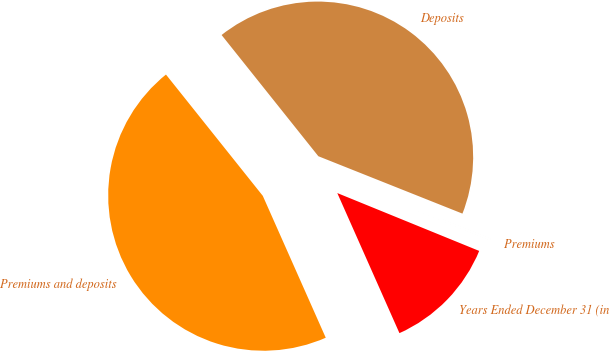Convert chart to OTSL. <chart><loc_0><loc_0><loc_500><loc_500><pie_chart><fcel>Years Ended December 31 (in<fcel>Premiums<fcel>Deposits<fcel>Premiums and deposits<nl><fcel>12.19%<fcel>0.13%<fcel>41.75%<fcel>45.92%<nl></chart> 